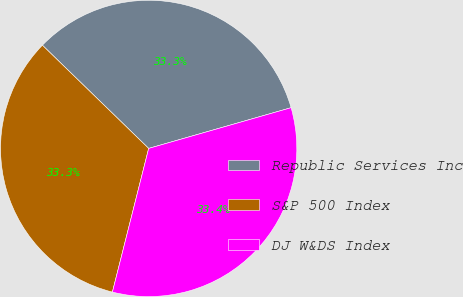Convert chart. <chart><loc_0><loc_0><loc_500><loc_500><pie_chart><fcel>Republic Services Inc<fcel>S&P 500 Index<fcel>DJ W&DS Index<nl><fcel>33.3%<fcel>33.33%<fcel>33.37%<nl></chart> 